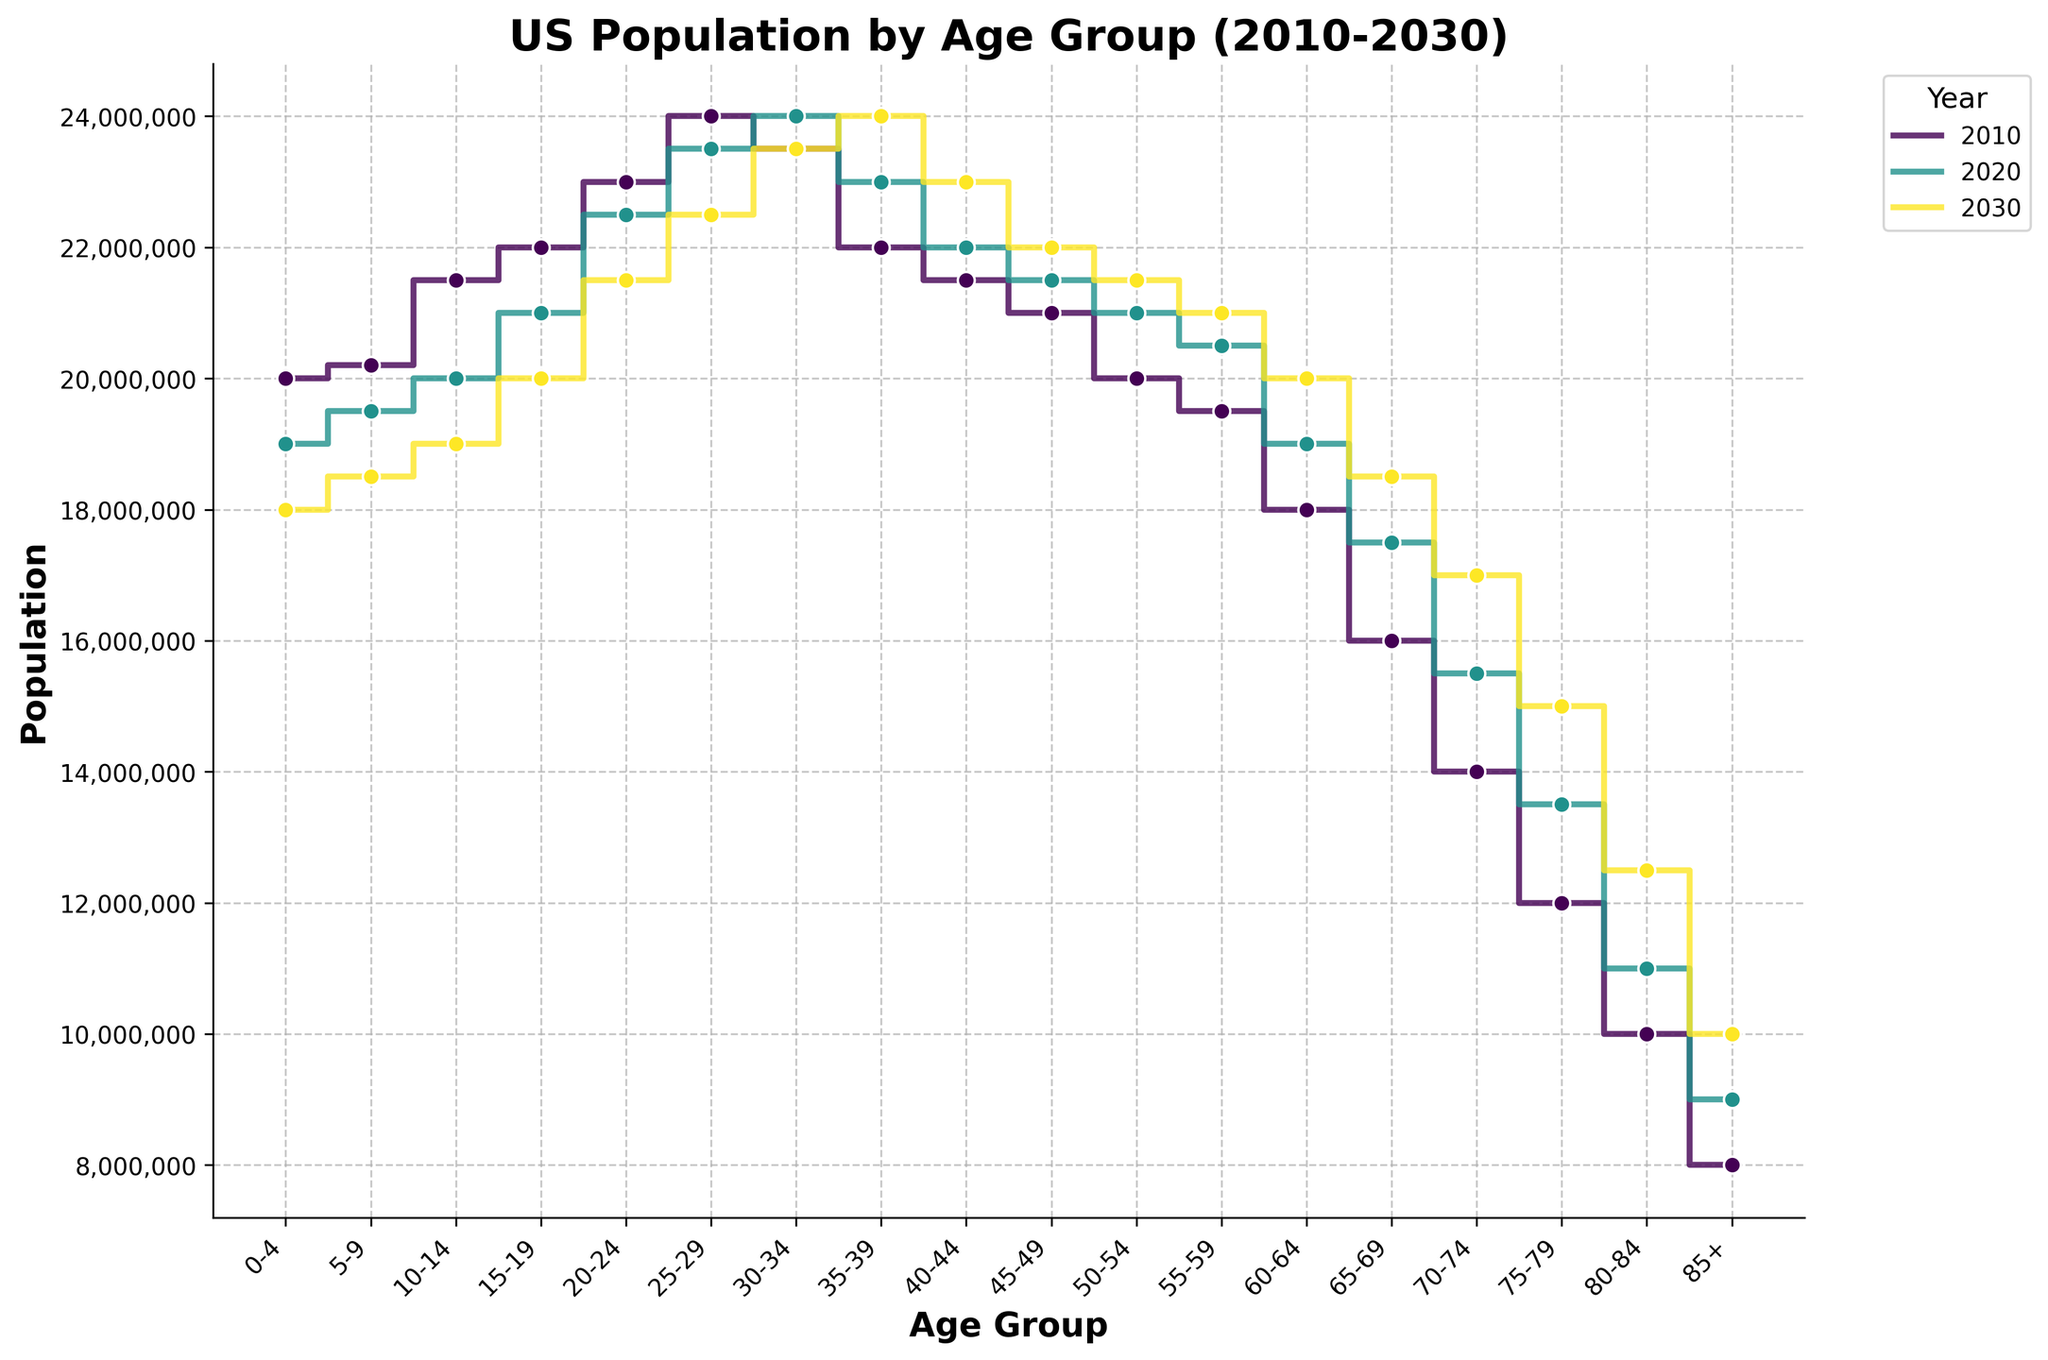what is the title of the figure? The title of a figure is typically found at the top and is designed to provide a quick understanding of the content and context of the plot. By inspecting the top of the figure, you would find the text "US Population by Age Group (2010-2030)" which serves as the title.
Answer: US Population by Age Group (2010-2030) what are the age groups represented on the x-axis? The x-axis of the plot shows the various age groups for the population data. By examining the labels along the x-axis, we identify the range of age groups as: "0-4, 5-9, 10-14, 15-19, 20-24, 25-29, 30-34, 35-39, 40-44, 45-49, 50-54, 55-59, 60-64, 65-69, 70-74, 75-79, 80-84, 85+".
Answer: 0-4, 5-9, 10-14, 15-19, 20-24, 25-29, 30-34, 35-39, 40-44, 45-49, 50-54, 55-59, 60-64, 65-69, 70-74, 75-79, 80-84, 85+ which year had the highest population for the age group 30-34? To determine which year had the highest population for a specific age group, we need to compare the stair steps corresponding to age group "30-34" across different years. Examining the plot, the 2020 line reaches the highest point among the three years for age group "30-34".
Answer: 2020 what is the difference in population between age groups 0-4 and 85+ in the year 2020? To find the difference in population for a specific year and between age groups, locate the population points of the respective age groups for that year. For 2020, the population at age 0-4 is 19,000,000 and for age 85+ is 9,000,000. The difference is calculated as 19,000,000 - 9,000,000.
Answer: 10,000,000 how does the population of the age group 75-79 change from 2010 to 2030? To understand the change over time for an age group, compare the population values at the start and end years. For age group "75-79", the population in 2010 is 12,000,000, and in 2030 it is 15,000,000. The population increased by 3,000,000.
Answer: Increased by 3,000,000 which age group has the lowest population in 2030? To identify the age group with the lowest population for a specific year, compare the height of the stair steps for all age groups in that year. For 2030, the "0-4" age group has the shortest step at 18,000,000, which is the lowest among all age groups.
Answer: 0-4 what is the average population across all age groups in 2020? Calculate the average population for a year by summing the population values of all age groups and then dividing by the number of age groups. Sum of populations for all age groups in 2020: 19M + 19.5M + 20M + 21M + 22.5M + 23.5M + 24M + 23M + 22M + 21.5M + 21M + 20.5M + 19M + 17.5M + 15.5M + 13.5M + 11M + 9M = 326.5M. There are 18 age groups, so the average is 326.5M / 18.
Answer: Approx. 18,138,889 